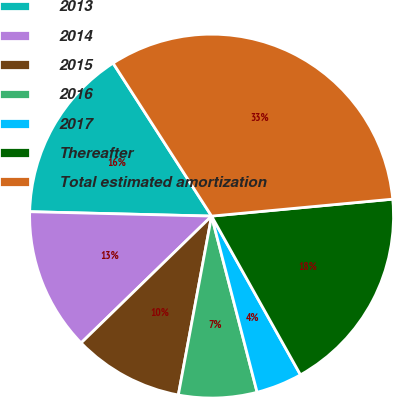Convert chart to OTSL. <chart><loc_0><loc_0><loc_500><loc_500><pie_chart><fcel>2013<fcel>2014<fcel>2015<fcel>2016<fcel>2017<fcel>Thereafter<fcel>Total estimated amortization<nl><fcel>15.51%<fcel>12.66%<fcel>9.8%<fcel>6.95%<fcel>4.1%<fcel>18.36%<fcel>32.62%<nl></chart> 